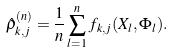<formula> <loc_0><loc_0><loc_500><loc_500>\hat { \rho } ^ { ( n ) } _ { k , j } = \frac { 1 } { n } \sum _ { l = 1 } ^ { n } f _ { k , j } ( X _ { l } , \Phi _ { l } ) .</formula> 